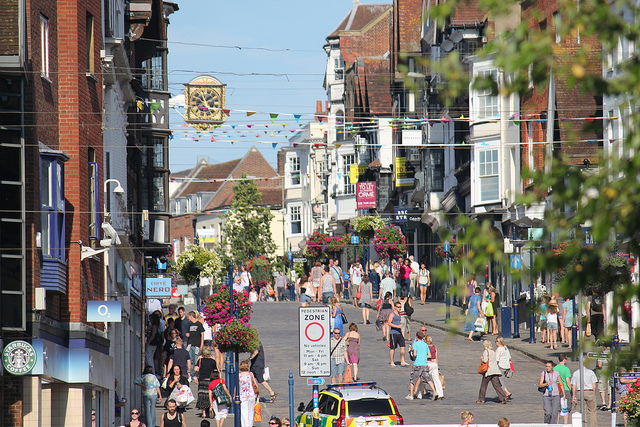Please transcribe the text information in this image. ZONE TOUT NCAD COFFEE STARBUCKS O 